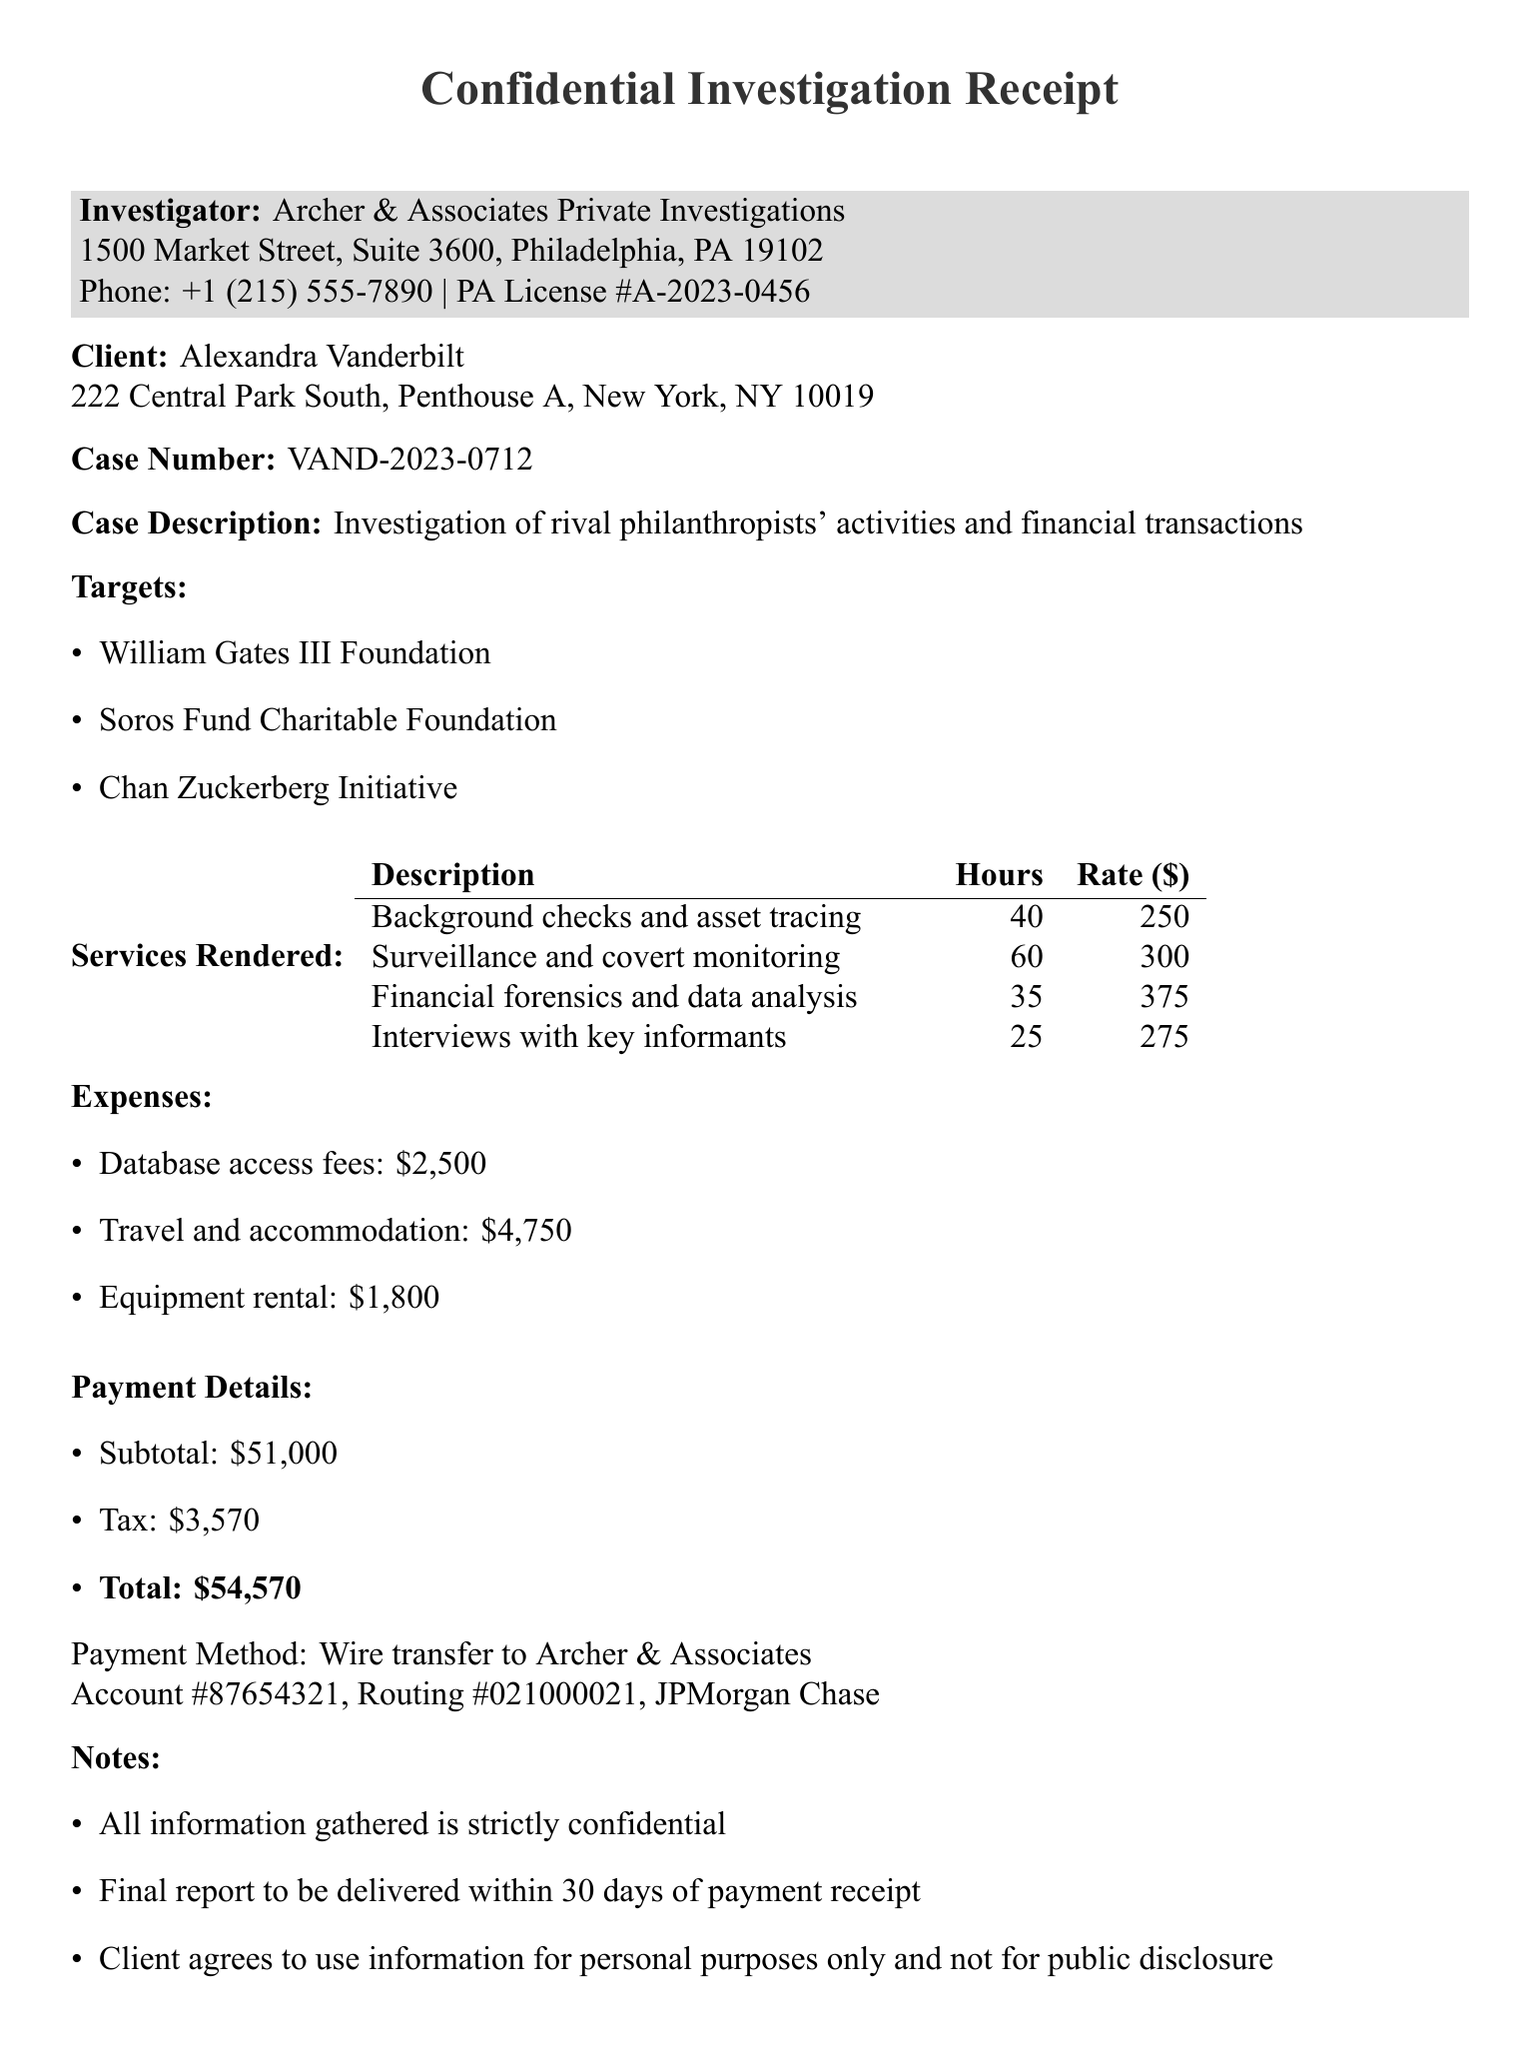What is the name of the investigator? The investigator is Archer & Associates Private Investigations, as stated in the document.
Answer: Archer & Associates Private Investigations What is the case number? The case number is directly listed in the document for reference.
Answer: VAND-2023-0712 How many hours were spent on surveillance and covert monitoring? The document specifies the number of hours dedicated to each service rendered.
Answer: 60 What was the subtotal amount for the services rendered? The subtotal amount is clearly indicated in the payment details section.
Answer: 51000 What is the total amount due? The total amount is the sum of the subtotal and tax, explicitly mentioned in the document.
Answer: 54570 Which foundation is NOT a target of the investigation? The list of targets is included in the document, and this question requires identifying one that is not mentioned.
Answer: (Any unnamed foundation) Who is the lead investigator? The lead investigator's name is provided at the end of the document where signatures are recorded.
Answer: Jonathan Archer What was the payment method used? The document states the payment method in the payment details section.
Answer: Wire transfer What is the deadline for the final report delivery? The document notes that the report will be delivered within a specific timeframe after payment receipt.
Answer: 30 days 